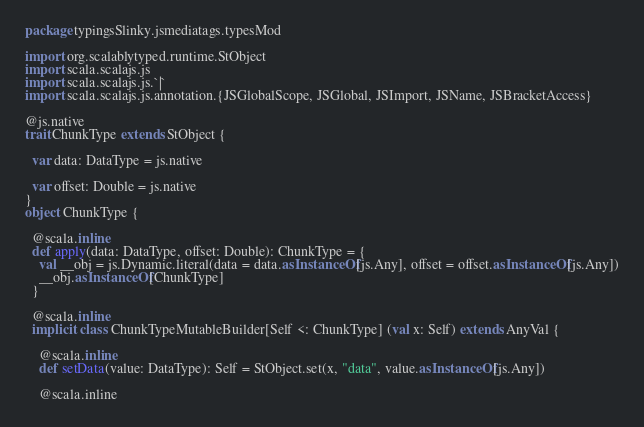Convert code to text. <code><loc_0><loc_0><loc_500><loc_500><_Scala_>package typingsSlinky.jsmediatags.typesMod

import org.scalablytyped.runtime.StObject
import scala.scalajs.js
import scala.scalajs.js.`|`
import scala.scalajs.js.annotation.{JSGlobalScope, JSGlobal, JSImport, JSName, JSBracketAccess}

@js.native
trait ChunkType extends StObject {
  
  var data: DataType = js.native
  
  var offset: Double = js.native
}
object ChunkType {
  
  @scala.inline
  def apply(data: DataType, offset: Double): ChunkType = {
    val __obj = js.Dynamic.literal(data = data.asInstanceOf[js.Any], offset = offset.asInstanceOf[js.Any])
    __obj.asInstanceOf[ChunkType]
  }
  
  @scala.inline
  implicit class ChunkTypeMutableBuilder[Self <: ChunkType] (val x: Self) extends AnyVal {
    
    @scala.inline
    def setData(value: DataType): Self = StObject.set(x, "data", value.asInstanceOf[js.Any])
    
    @scala.inline</code> 